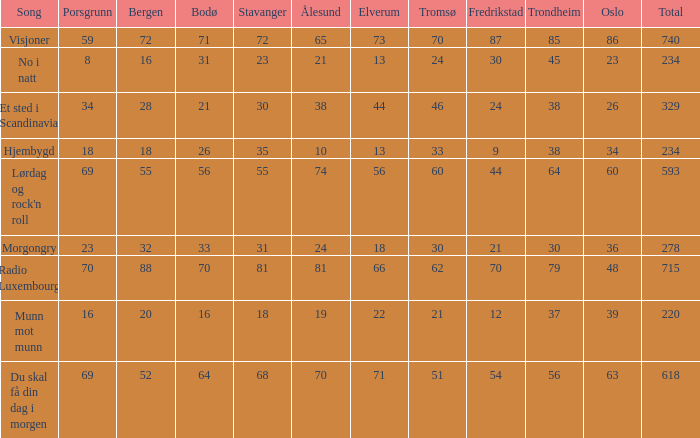At the age of 88 for bergen, what is the value of alesund? 81.0. Can you give me this table as a dict? {'header': ['Song', 'Porsgrunn', 'Bergen', 'Bodø', 'Stavanger', 'Ålesund', 'Elverum', 'Tromsø', 'Fredrikstad', 'Trondheim', 'Oslo', 'Total'], 'rows': [['Visjoner', '59', '72', '71', '72', '65', '73', '70', '87', '85', '86', '740'], ['No i natt', '8', '16', '31', '23', '21', '13', '24', '30', '45', '23', '234'], ['Et sted i Scandinavia', '34', '28', '21', '30', '38', '44', '46', '24', '38', '26', '329'], ['Hjembygd', '18', '18', '26', '35', '10', '13', '33', '9', '38', '34', '234'], ["Lørdag og rock'n roll", '69', '55', '56', '55', '74', '56', '60', '44', '64', '60', '593'], ['Morgongry', '23', '32', '33', '31', '24', '18', '30', '21', '30', '36', '278'], ['Radio Luxembourg', '70', '88', '70', '81', '81', '66', '62', '70', '79', '48', '715'], ['Munn mot munn', '16', '20', '16', '18', '19', '22', '21', '12', '37', '39', '220'], ['Du skal få din dag i morgen', '69', '52', '64', '68', '70', '71', '51', '54', '56', '63', '618']]} 